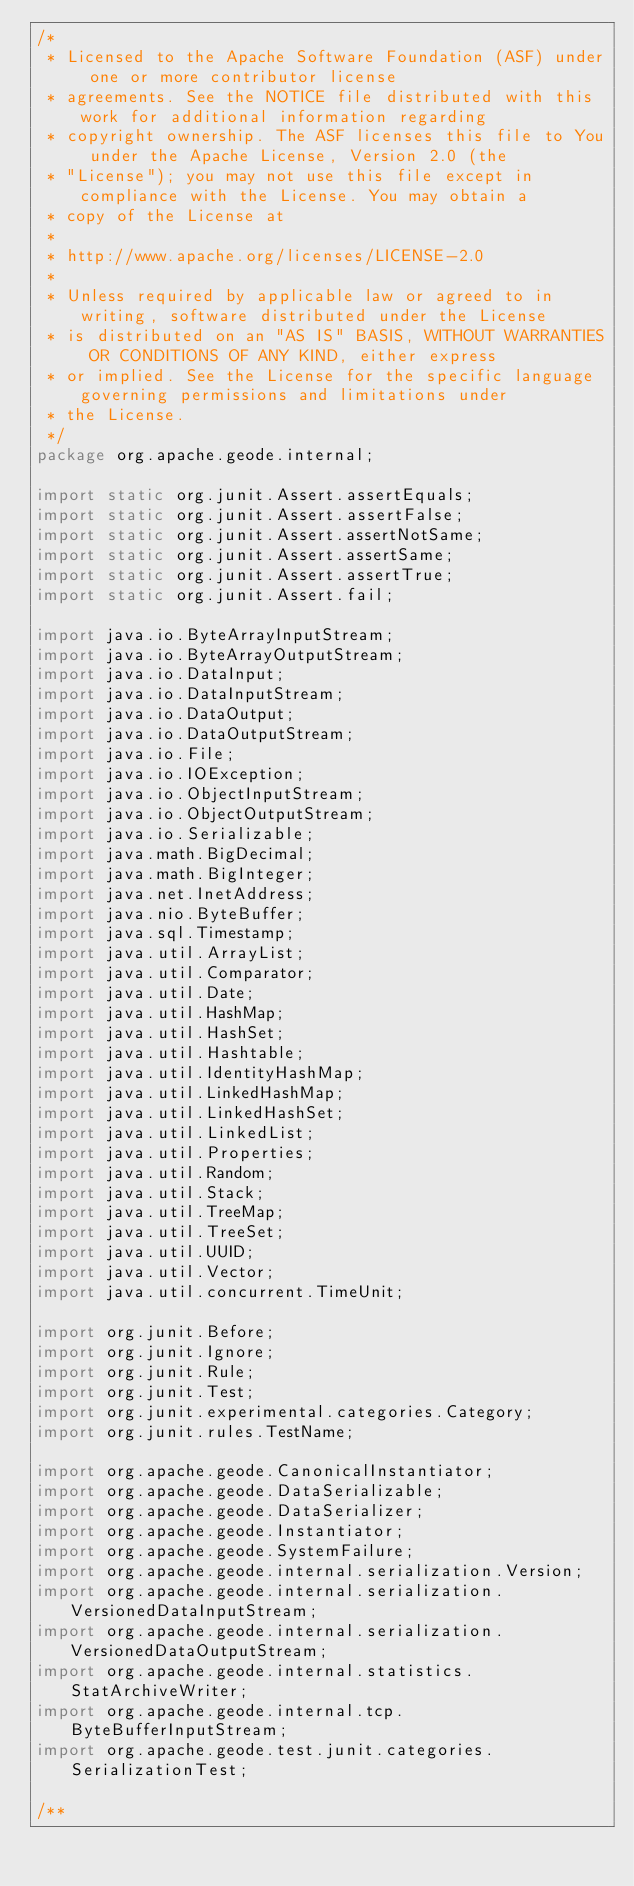<code> <loc_0><loc_0><loc_500><loc_500><_Java_>/*
 * Licensed to the Apache Software Foundation (ASF) under one or more contributor license
 * agreements. See the NOTICE file distributed with this work for additional information regarding
 * copyright ownership. The ASF licenses this file to You under the Apache License, Version 2.0 (the
 * "License"); you may not use this file except in compliance with the License. You may obtain a
 * copy of the License at
 *
 * http://www.apache.org/licenses/LICENSE-2.0
 *
 * Unless required by applicable law or agreed to in writing, software distributed under the License
 * is distributed on an "AS IS" BASIS, WITHOUT WARRANTIES OR CONDITIONS OF ANY KIND, either express
 * or implied. See the License for the specific language governing permissions and limitations under
 * the License.
 */
package org.apache.geode.internal;

import static org.junit.Assert.assertEquals;
import static org.junit.Assert.assertFalse;
import static org.junit.Assert.assertNotSame;
import static org.junit.Assert.assertSame;
import static org.junit.Assert.assertTrue;
import static org.junit.Assert.fail;

import java.io.ByteArrayInputStream;
import java.io.ByteArrayOutputStream;
import java.io.DataInput;
import java.io.DataInputStream;
import java.io.DataOutput;
import java.io.DataOutputStream;
import java.io.File;
import java.io.IOException;
import java.io.ObjectInputStream;
import java.io.ObjectOutputStream;
import java.io.Serializable;
import java.math.BigDecimal;
import java.math.BigInteger;
import java.net.InetAddress;
import java.nio.ByteBuffer;
import java.sql.Timestamp;
import java.util.ArrayList;
import java.util.Comparator;
import java.util.Date;
import java.util.HashMap;
import java.util.HashSet;
import java.util.Hashtable;
import java.util.IdentityHashMap;
import java.util.LinkedHashMap;
import java.util.LinkedHashSet;
import java.util.LinkedList;
import java.util.Properties;
import java.util.Random;
import java.util.Stack;
import java.util.TreeMap;
import java.util.TreeSet;
import java.util.UUID;
import java.util.Vector;
import java.util.concurrent.TimeUnit;

import org.junit.Before;
import org.junit.Ignore;
import org.junit.Rule;
import org.junit.Test;
import org.junit.experimental.categories.Category;
import org.junit.rules.TestName;

import org.apache.geode.CanonicalInstantiator;
import org.apache.geode.DataSerializable;
import org.apache.geode.DataSerializer;
import org.apache.geode.Instantiator;
import org.apache.geode.SystemFailure;
import org.apache.geode.internal.serialization.Version;
import org.apache.geode.internal.serialization.VersionedDataInputStream;
import org.apache.geode.internal.serialization.VersionedDataOutputStream;
import org.apache.geode.internal.statistics.StatArchiveWriter;
import org.apache.geode.internal.tcp.ByteBufferInputStream;
import org.apache.geode.test.junit.categories.SerializationTest;

/**</code> 